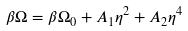<formula> <loc_0><loc_0><loc_500><loc_500>\beta \Omega = \beta \Omega _ { 0 } + A _ { 1 } \eta ^ { 2 } + A _ { 2 } \eta ^ { 4 }</formula> 